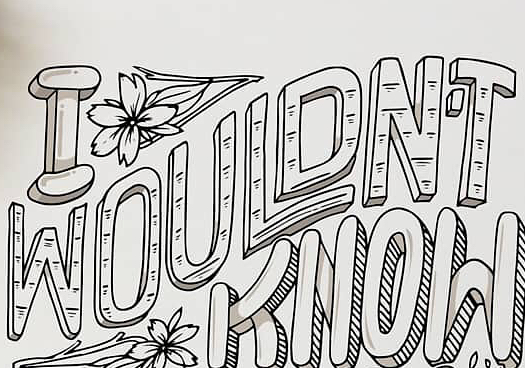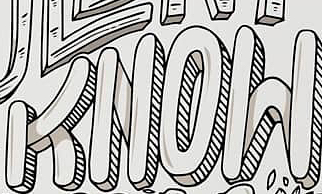What words are shown in these images in order, separated by a semicolon? WOULDN'T; KNOW 